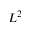<formula> <loc_0><loc_0><loc_500><loc_500>L ^ { 2 }</formula> 